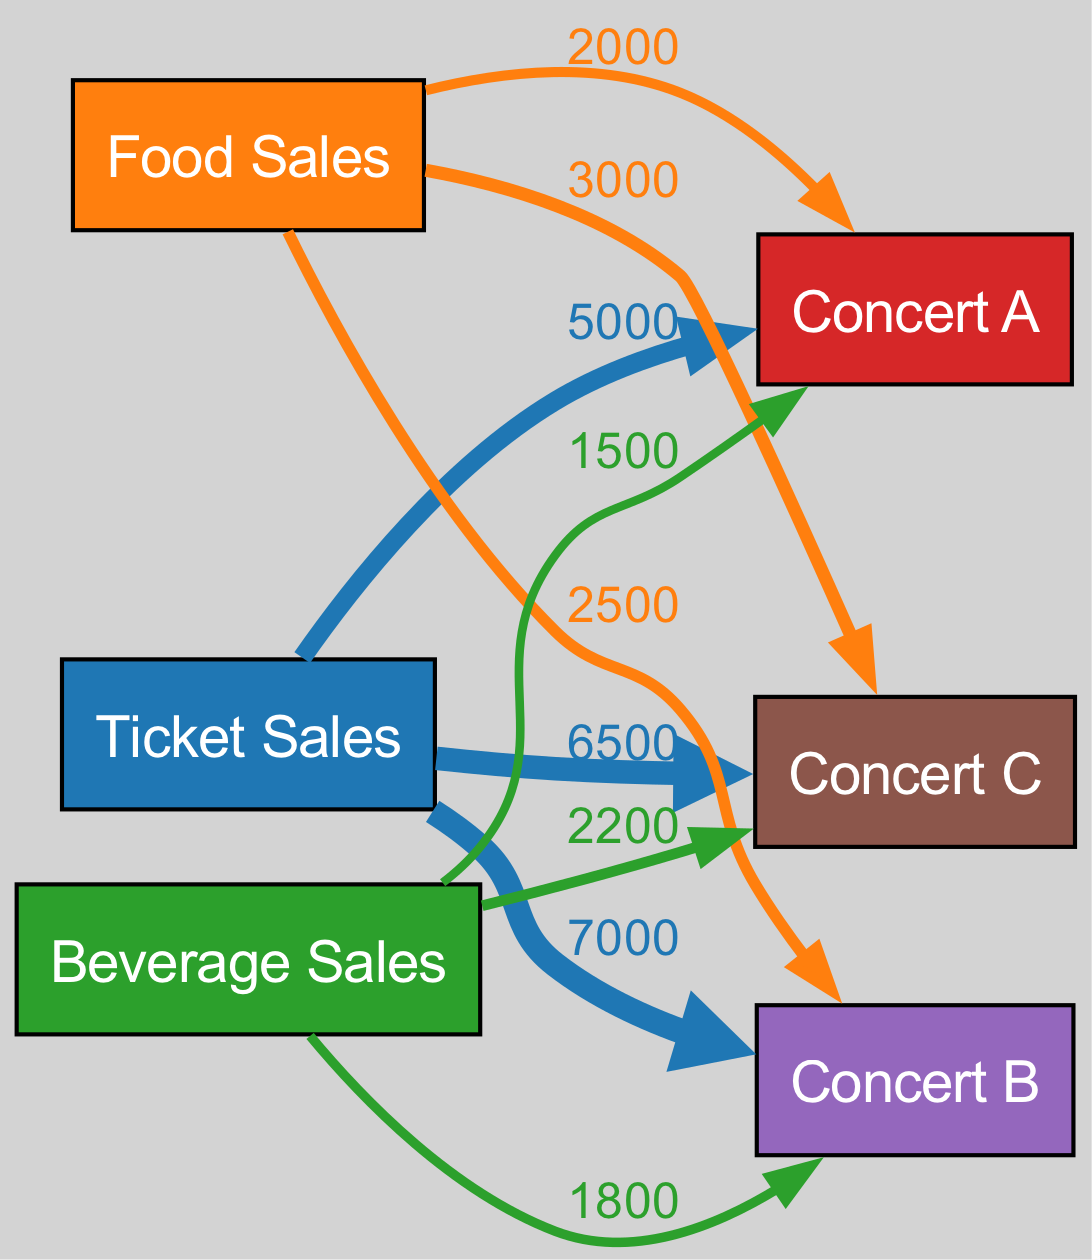What is the total value of ticket sales for Concert A? The flow from the 'Ticket Sales' node to 'Concert A' shows a value of 5000. Therefore, the total value of ticket sales for Concert A is 5000.
Answer: 5000 Which concert has the highest food sales? Looking at the flows from the 'Food Sales' node, Concert C shows the highest value of 3000, while Concert B has 2500 and Concert A has 2000. Hence, the highest food sales are for Concert C.
Answer: Concert C What is the total revenue from beverage sales across all concerts? The beverage sales are 1500 for Concert A, 1800 for Concert B, and 2200 for Concert C. Adding these values together (1500 + 1800 + 2200) gives a total of 5500 from beverage sales across all concerts.
Answer: 5500 Which concert generates the most overall revenue from ticket, food, and beverage sales combined? The total revenues are calculated by adding all flows for each concert: 
- Concert A: 5000 (Ticket) + 2000 (Food) + 1500 (Beverage) = 8500 
- Concert B: 7000 (Ticket) + 2500 (Food) + 1800 (Beverage) = 11300 
- Concert C: 6500 (Ticket) + 3000 (Food) + 2200 (Beverage) = 11700 
Hence, Concert C generates the most overall revenue at 11700.
Answer: Concert C How many nodes are present in the diagram? The nodes include 'Ticket Sales', 'Food Sales', 'Beverage Sales', 'Concert A', 'Concert B', and 'Concert C', totaling 6 nodes.
Answer: 6 What is the flow value for beverage sales for Concert B? The flow from 'Beverage Sales' to 'Concert B' is indicated to be 1800. Thus, the flow value for beverage sales for Concert B is 1800.
Answer: 1800 